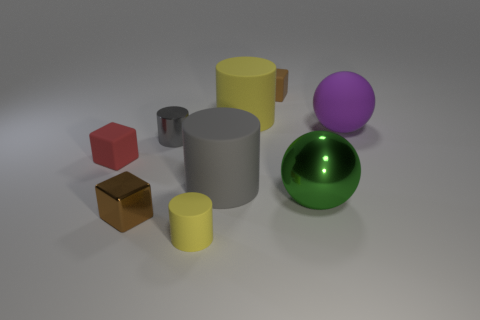How many other objects are there of the same color as the shiny cylinder?
Offer a terse response. 1. What color is the object in front of the brown cube that is in front of the green ball?
Provide a succinct answer. Yellow. Are there any big cylinders that have the same color as the large matte ball?
Offer a terse response. No. What number of matte objects are either blue cubes or small yellow things?
Your answer should be very brief. 1. Are there any tiny brown things made of the same material as the red block?
Provide a short and direct response. Yes. How many small brown cubes are both behind the large gray object and in front of the large matte ball?
Ensure brevity in your answer.  0. Is the number of cylinders to the left of the small red rubber thing less than the number of matte things in front of the small gray thing?
Offer a very short reply. Yes. Is the tiny red rubber thing the same shape as the brown matte thing?
Ensure brevity in your answer.  Yes. How many other things are there of the same size as the gray metallic cylinder?
Offer a very short reply. 4. What number of things are big objects that are left of the matte ball or yellow objects that are in front of the purple ball?
Give a very brief answer. 4. 